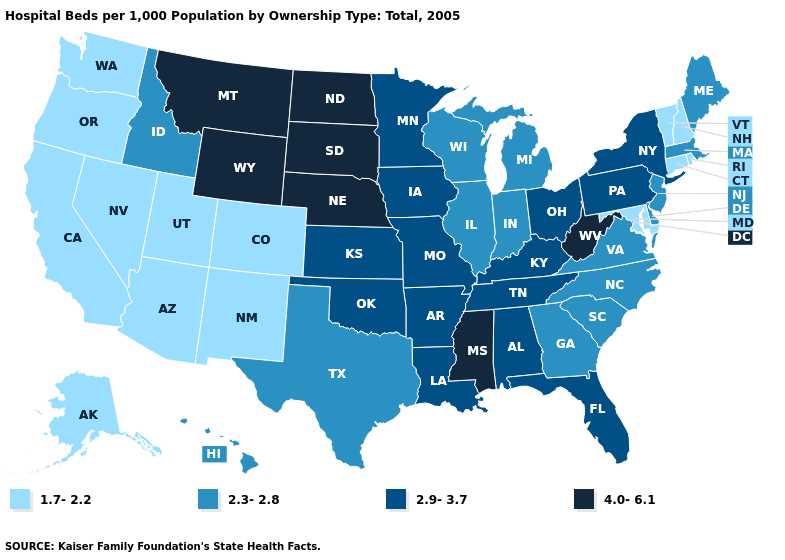Name the states that have a value in the range 2.3-2.8?
Short answer required. Delaware, Georgia, Hawaii, Idaho, Illinois, Indiana, Maine, Massachusetts, Michigan, New Jersey, North Carolina, South Carolina, Texas, Virginia, Wisconsin. Name the states that have a value in the range 1.7-2.2?
Keep it brief. Alaska, Arizona, California, Colorado, Connecticut, Maryland, Nevada, New Hampshire, New Mexico, Oregon, Rhode Island, Utah, Vermont, Washington. Among the states that border Wisconsin , which have the lowest value?
Short answer required. Illinois, Michigan. Does Georgia have the lowest value in the USA?
Concise answer only. No. Is the legend a continuous bar?
Answer briefly. No. What is the lowest value in the USA?
Concise answer only. 1.7-2.2. What is the lowest value in states that border Washington?
Answer briefly. 1.7-2.2. What is the lowest value in the USA?
Answer briefly. 1.7-2.2. What is the value of Kansas?
Keep it brief. 2.9-3.7. Does Montana have the highest value in the USA?
Concise answer only. Yes. Does the map have missing data?
Keep it brief. No. What is the value of Washington?
Answer briefly. 1.7-2.2. Does Tennessee have a higher value than Iowa?
Answer briefly. No. What is the lowest value in the West?
Concise answer only. 1.7-2.2. What is the value of Minnesota?
Keep it brief. 2.9-3.7. 